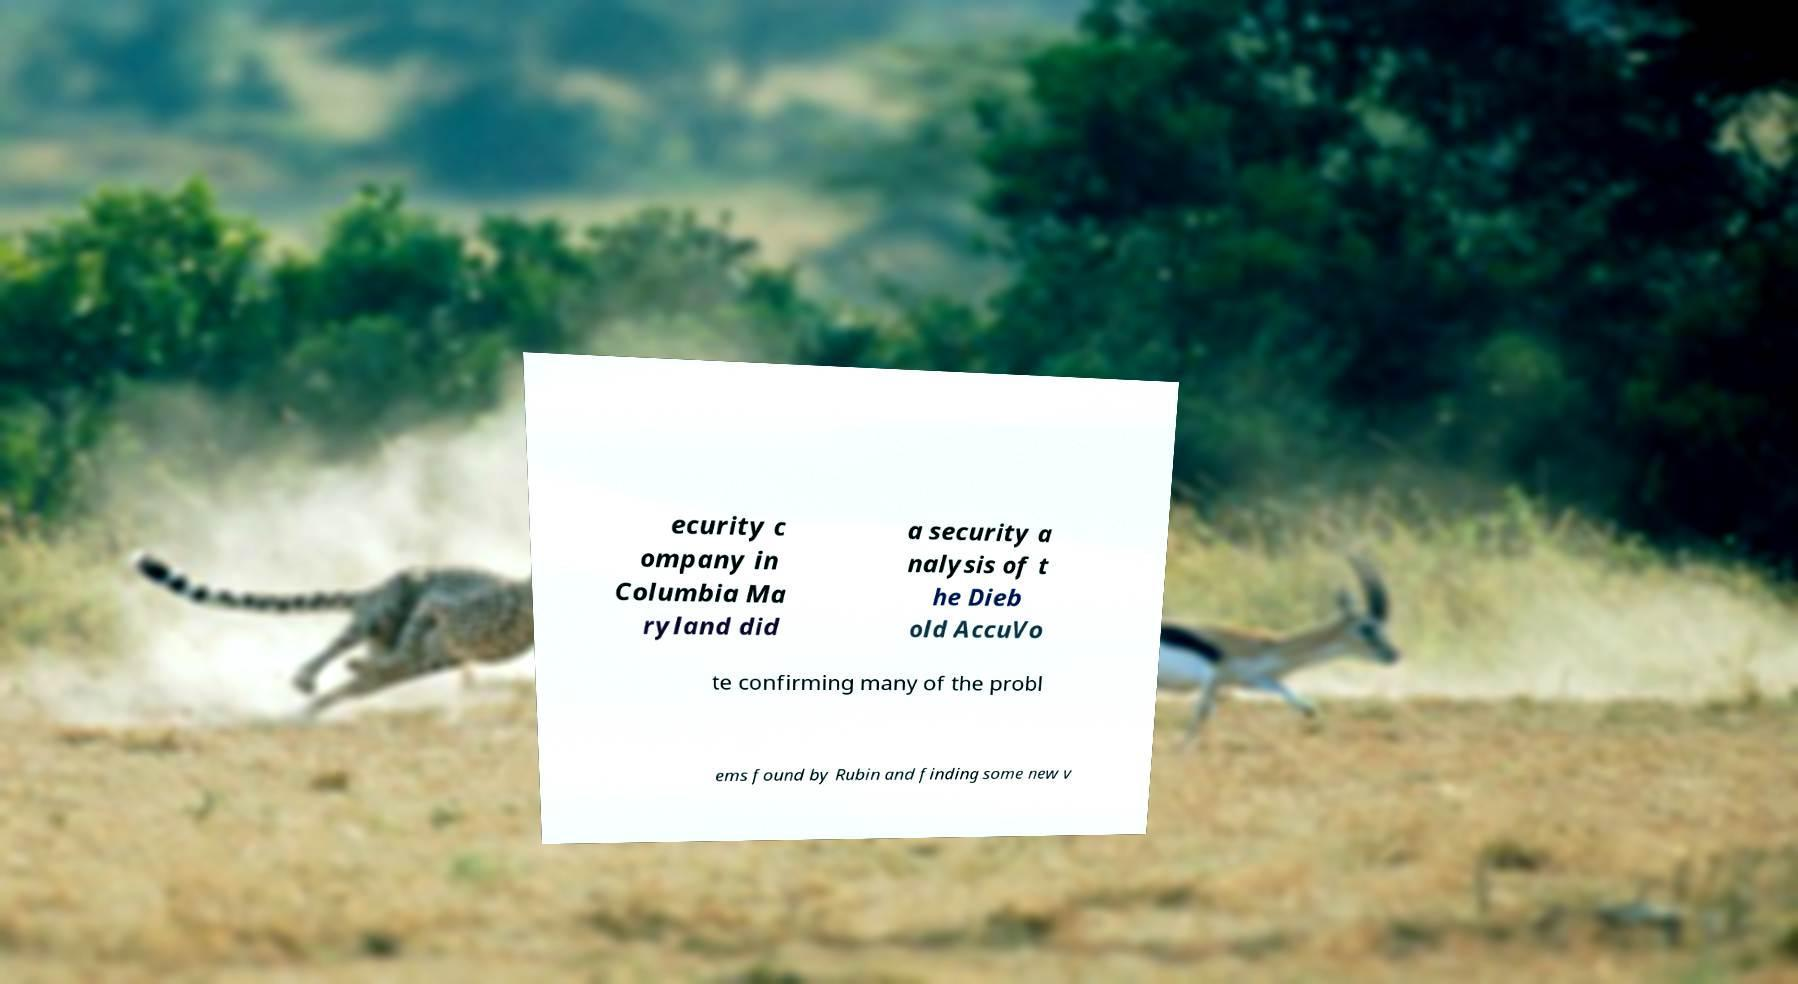For documentation purposes, I need the text within this image transcribed. Could you provide that? ecurity c ompany in Columbia Ma ryland did a security a nalysis of t he Dieb old AccuVo te confirming many of the probl ems found by Rubin and finding some new v 